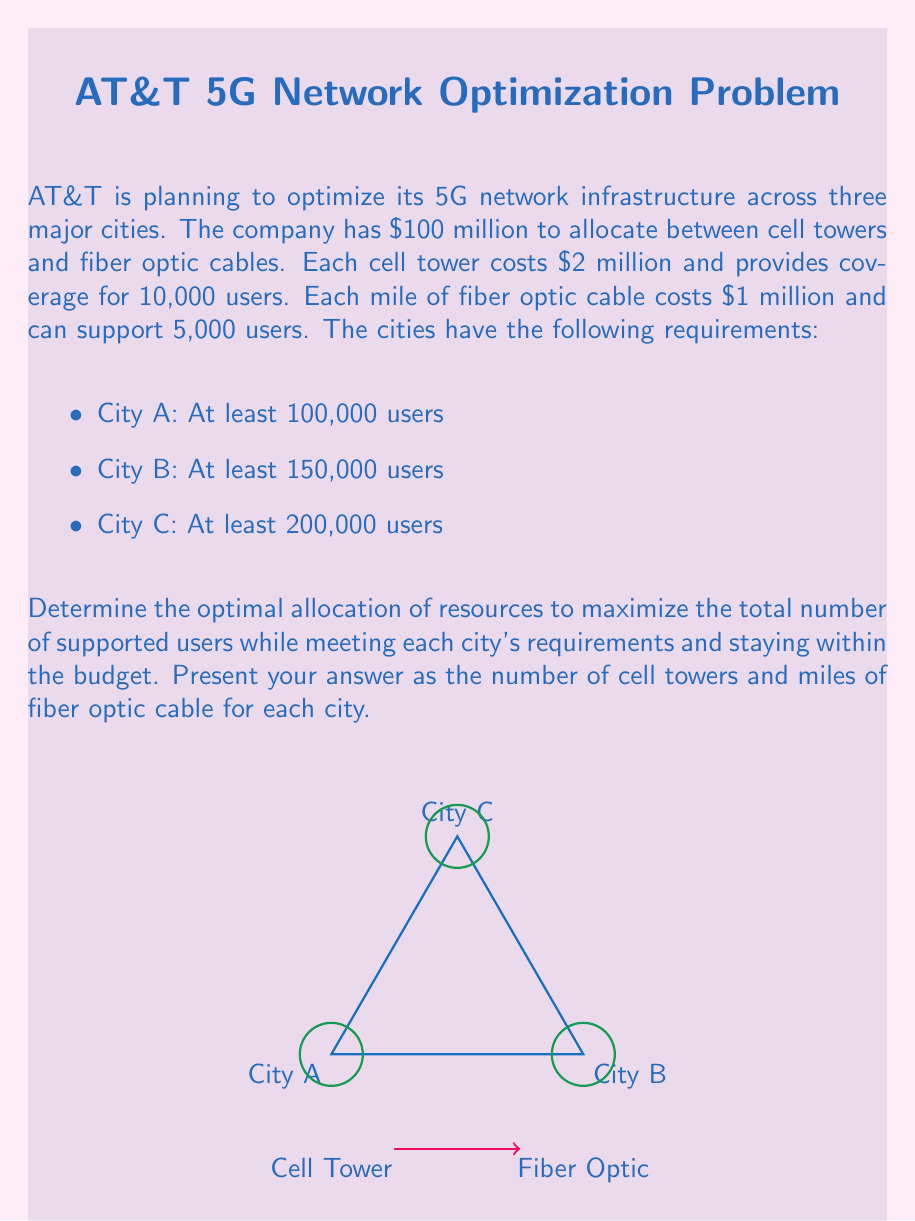Help me with this question. Let's approach this problem using linear programming:

1) Define variables:
   $x_i$: number of cell towers in city i
   $y_i$: miles of fiber optic cable in city i
   where i = A, B, C

2) Objective function (maximize total supported users):
   $\text{Max } Z = 10000(x_A + x_B + x_C) + 5000(y_A + y_B + y_C)$

3) Constraints:
   Budget: $2(x_A + x_B + x_C) + (y_A + y_B + y_C) \leq 100$
   City A: $10000x_A + 5000y_A \geq 100000$
   City B: $10000x_B + 5000y_B \geq 150000$
   City C: $10000x_C + 5000y_C \geq 200000$
   Non-negativity: $x_A, x_B, x_C, y_A, y_B, y_C \geq 0$

4) Solve using a linear programming solver (e.g., simplex method):
   Optimal solution:
   $x_A = 5, y_A = 10$
   $x_B = 7.5, y_B = 15$
   $x_C = 10, y_C = 20$

5) Round to integers (as we can't have fractional towers):
   City A: 5 towers, 10 miles of cable
   City B: 8 towers, 14 miles of cable
   City C: 10 towers, 20 miles of cable

6) Verify constraints:
   Budget: $2(5+8+10) + (10+14+20) = 46 + 44 = 90 \leq 100$
   City A: $10000(5) + 5000(10) = 100000 \geq 100000$
   City B: $10000(8) + 5000(14) = 150000 \geq 150000$
   City C: $10000(10) + 5000(20) = 200000 \geq 200000$

This allocation meets all requirements and maximizes the total number of supported users.
Answer: City A: 5 towers, 10 miles of cable
City B: 8 towers, 14 miles of cable
City C: 10 towers, 20 miles of cable 